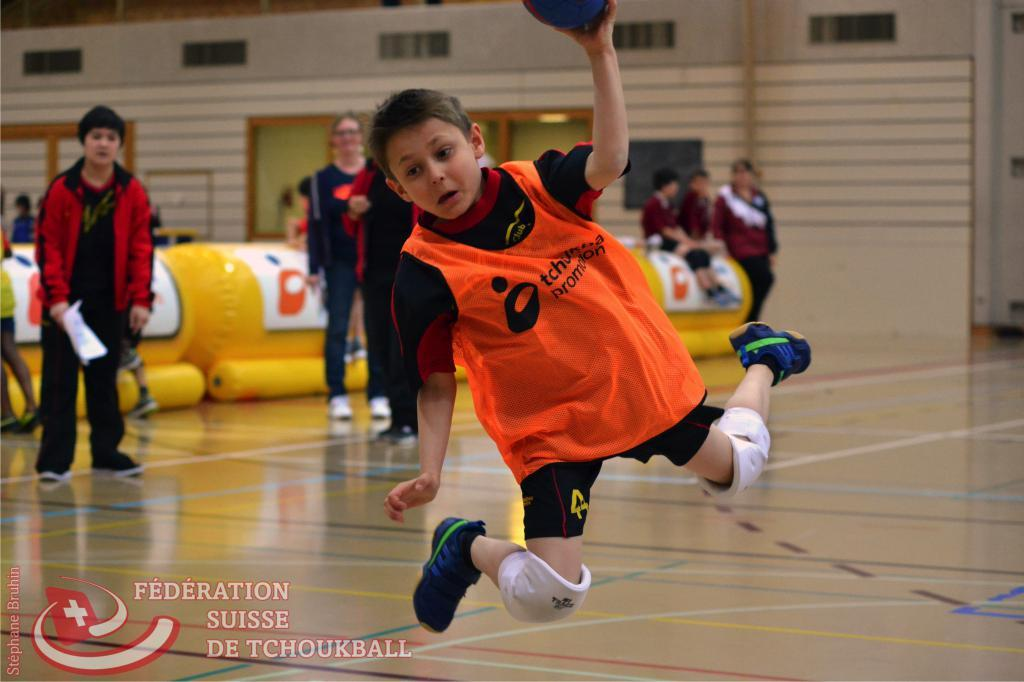What is the main subject of the image? The main subject of the image is a boy. What is the boy doing in the image? The boy is jumping into the air. What is the boy holding in his hand? The boy is holding a ball in his hand. What can be seen in the background of the image? There is a wall, ventilators, windows, and persons standing on the floor in the background of the image. Can you tell me how many jellyfish are swimming in the background of the image? There are no jellyfish present in the image; the background features a wall, ventilators, windows, and persons standing on the floor. 